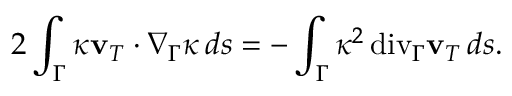Convert formula to latex. <formula><loc_0><loc_0><loc_500><loc_500>2 \int _ { \Gamma } \kappa \mathbf v _ { T } \cdot \nabla _ { \Gamma } \kappa \, d s = - \int _ { \Gamma } \kappa ^ { 2 } { \, d i v } _ { \Gamma } \mathbf v _ { T } \, d s .</formula> 